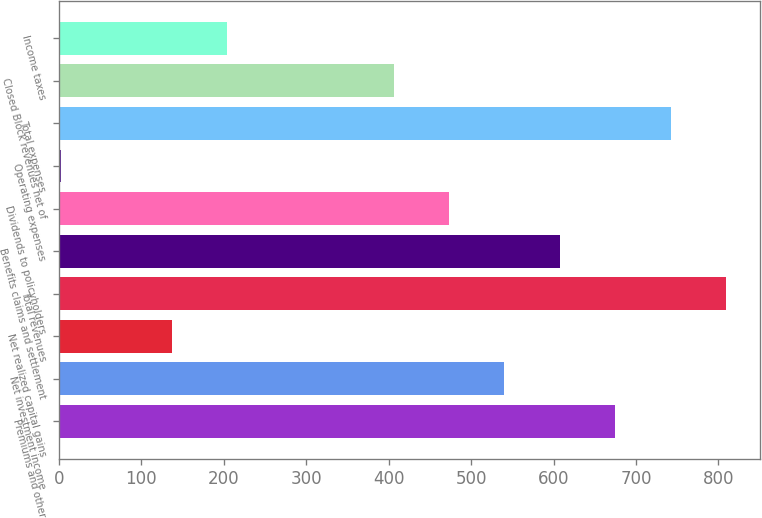Convert chart. <chart><loc_0><loc_0><loc_500><loc_500><bar_chart><fcel>Premiums and other<fcel>Net investment income<fcel>Net realized capital gains<fcel>Total revenues<fcel>Benefits claims and settlement<fcel>Dividends to policyholders<fcel>Operating expenses<fcel>Total expenses<fcel>Closed Block revenues net of<fcel>Income taxes<nl><fcel>674.9<fcel>540.5<fcel>137.3<fcel>809.3<fcel>607.7<fcel>473.3<fcel>2.9<fcel>742.1<fcel>406.1<fcel>204.5<nl></chart> 